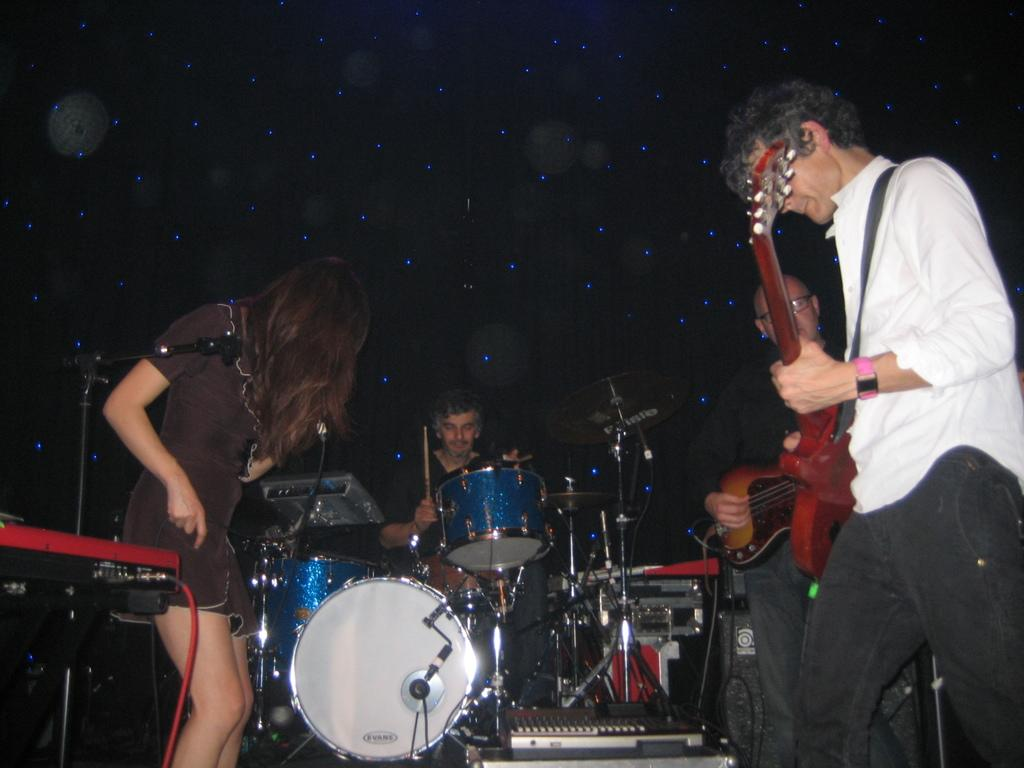How many people are in the image? There are three men and a woman in the image. What are two of the men doing in the image? Two men are playing the guitar. What is the third man doing in the image? The man sitting is playing the drums. What type of milk is being used to learn the music in the image? There is no milk or learning process depicted in the image; it features three men and a woman playing musical instruments. 